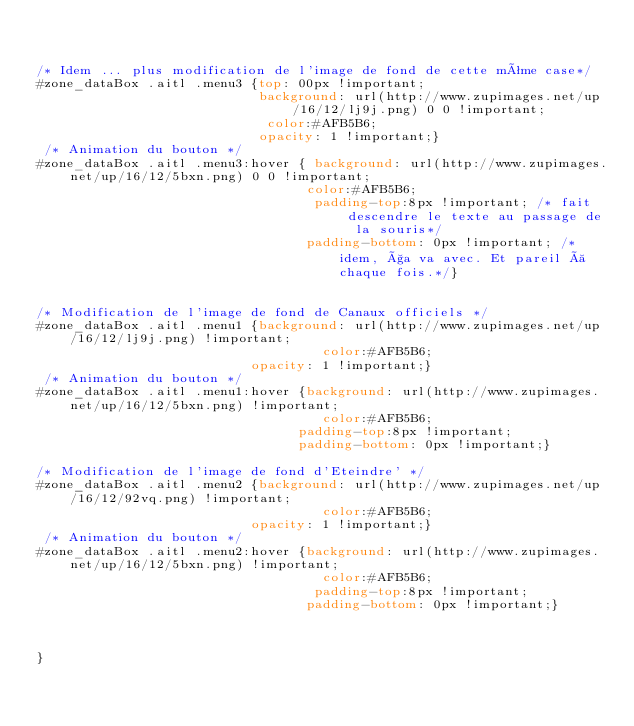Convert code to text. <code><loc_0><loc_0><loc_500><loc_500><_CSS_>  
  
/* Idem ... plus modification de l'image de fond de cette même case*/
#zone_dataBox .aitl .menu3 {top: 00px !important;
                            background: url(http://www.zupimages.net/up/16/12/lj9j.png) 0 0 !important;
                             color:#AFB5B6;
                            opacity: 1 !important;}
 /* Animation du bouton */
#zone_dataBox .aitl .menu3:hover { background: url(http://www.zupimages.net/up/16/12/5bxn.png) 0 0 !important;
                                  color:#AFB5B6;
                                   padding-top:8px !important; /* fait descendre le texte au passage de la souris*/
                                  padding-bottom: 0px !important; /* idem, ça va avec. Et pareil à chaque fois.*/}
  
  
/* Modification de l'image de fond de Canaux officiels */
#zone_dataBox .aitl .menu1 {background: url(http://www.zupimages.net/up/16/12/lj9j.png) !important;
                                    color:#AFB5B6;
                           opacity: 1 !important;}
 /* Animation du bouton */
#zone_dataBox .aitl .menu1:hover {background: url(http://www.zupimages.net/up/16/12/5bxn.png) !important;
                                    color:#AFB5B6;
                                 padding-top:8px !important;
                                 padding-bottom: 0px !important;}
  
/* Modification de l'image de fond d'Eteindre' */
#zone_dataBox .aitl .menu2 {background: url(http://www.zupimages.net/up/16/12/92vq.png) !important;
                                    color:#AFB5B6;
                           opacity: 1 !important;}
 /* Animation du bouton */
#zone_dataBox .aitl .menu2:hover {background: url(http://www.zupimages.net/up/16/12/5bxn.png) !important;
                                    color:#AFB5B6;
                                   padding-top:8px !important;
                                  padding-bottom: 0px !important;}



}</code> 